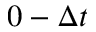<formula> <loc_0><loc_0><loc_500><loc_500>0 - \Delta t</formula> 